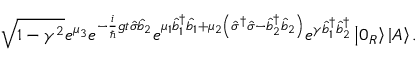Convert formula to latex. <formula><loc_0><loc_0><loc_500><loc_500>\sqrt { 1 - \gamma ^ { 2 } } e ^ { \mu _ { 3 } } e ^ { - \frac { i } { \hslash } g t \hat { \sigma } \hat { b } _ { 2 } } e ^ { \mu _ { 1 } \hat { b } _ { 1 } ^ { \dagger } \hat { b } _ { 1 } + \mu _ { 2 } \left ( \hat { \sigma } ^ { \dagger } \hat { \sigma } - \hat { b } _ { 2 } ^ { \dagger } \hat { b } _ { 2 } \right ) } e ^ { \gamma \hat { b } _ { 1 } ^ { \dagger } \hat { b } _ { 2 } ^ { \dagger } } \left | 0 _ { R } \right \rangle \left | A \right \rangle .</formula> 